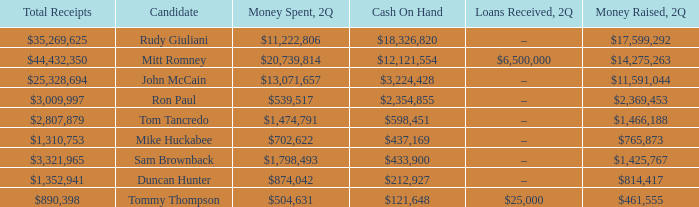Tell me the total receipts for tom tancredo $2,807,879. 